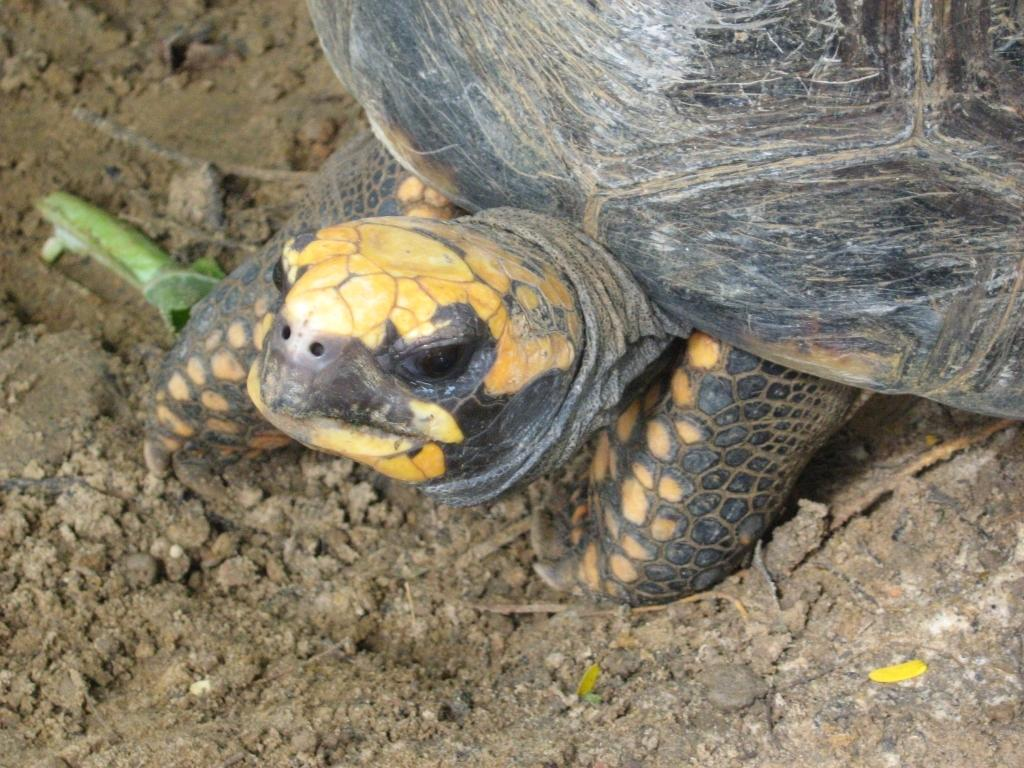What animal is the main subject of the picture? There is a tortoise in the picture. Where is the tortoise located in the image? The tortoise is on the ground. What colors can be seen on the tortoise's shell? The tortoise is black and light brown in color. What news headline is displayed on the tortoise's shell in the image? There is no news headline present on the tortoise's shell in the image. 